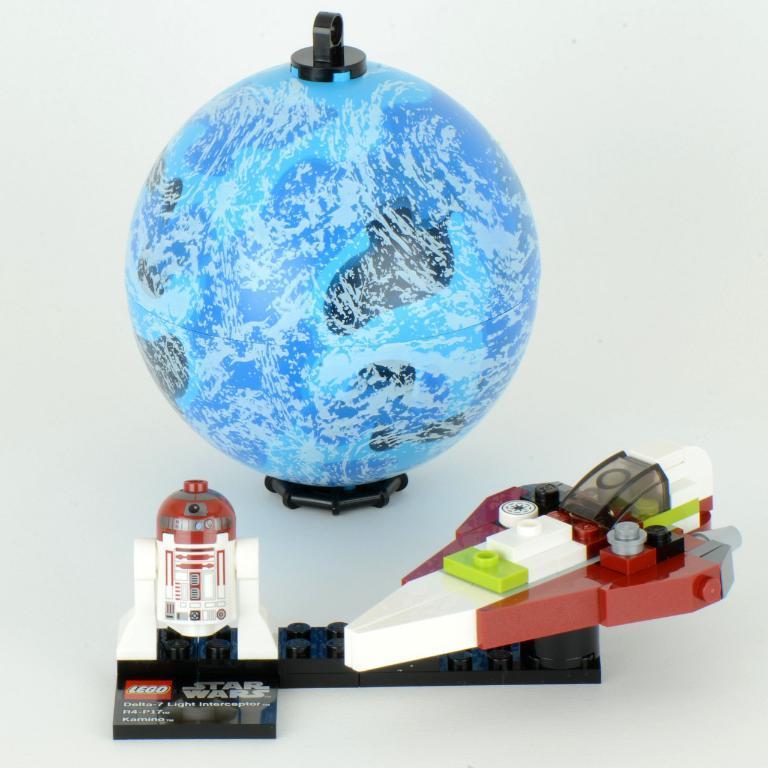Could you give a brief overview of what you see in this image? In the picture we can a toy rocket and toy aircraft and a globe. 